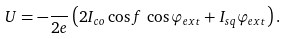<formula> <loc_0><loc_0><loc_500><loc_500>U = - \frac { } { 2 e } \left ( 2 I _ { c o } \cos f \, \cos \varphi _ { e x t } + I _ { s q } \varphi _ { e x t } \right ) .</formula> 